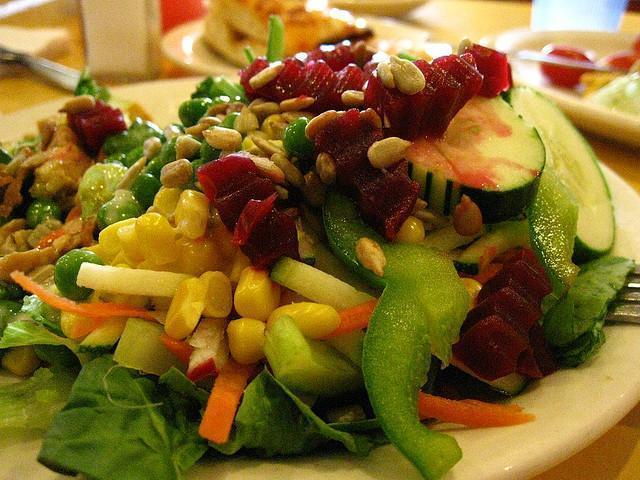How many carrots are in the photo?
Give a very brief answer. 2. How many women are in the picture?
Give a very brief answer. 0. 